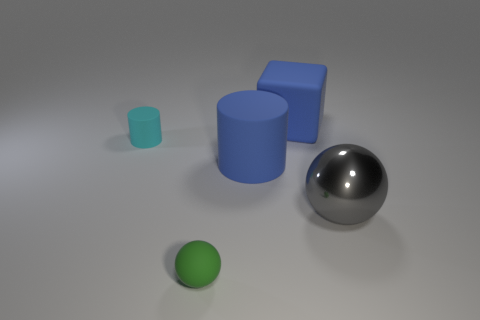Add 4 tiny cyan matte cylinders. How many objects exist? 9 Subtract all spheres. How many objects are left? 3 Subtract 0 red blocks. How many objects are left? 5 Subtract all small spheres. Subtract all big blue blocks. How many objects are left? 3 Add 4 large cubes. How many large cubes are left? 5 Add 5 rubber objects. How many rubber objects exist? 9 